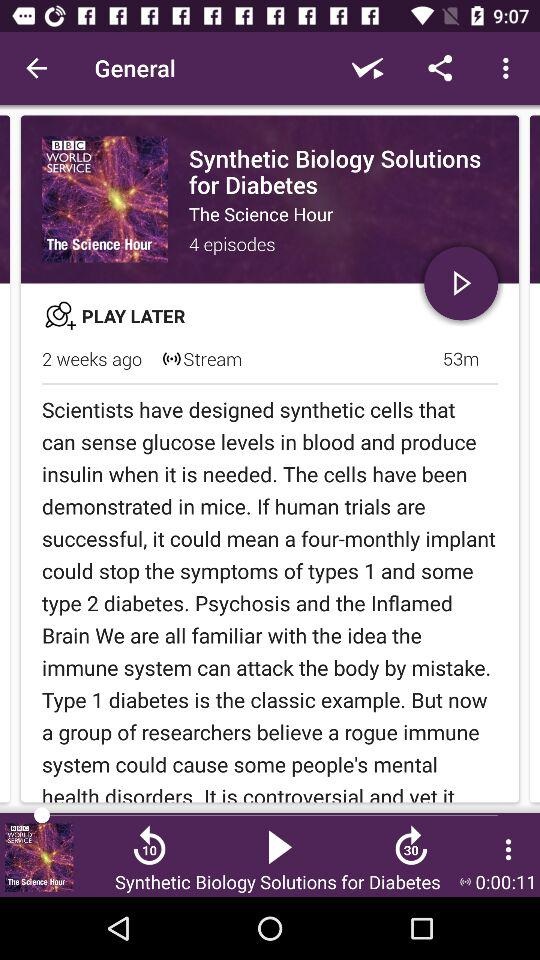How many episodes are there?
Answer the question using a single word or phrase. 4 